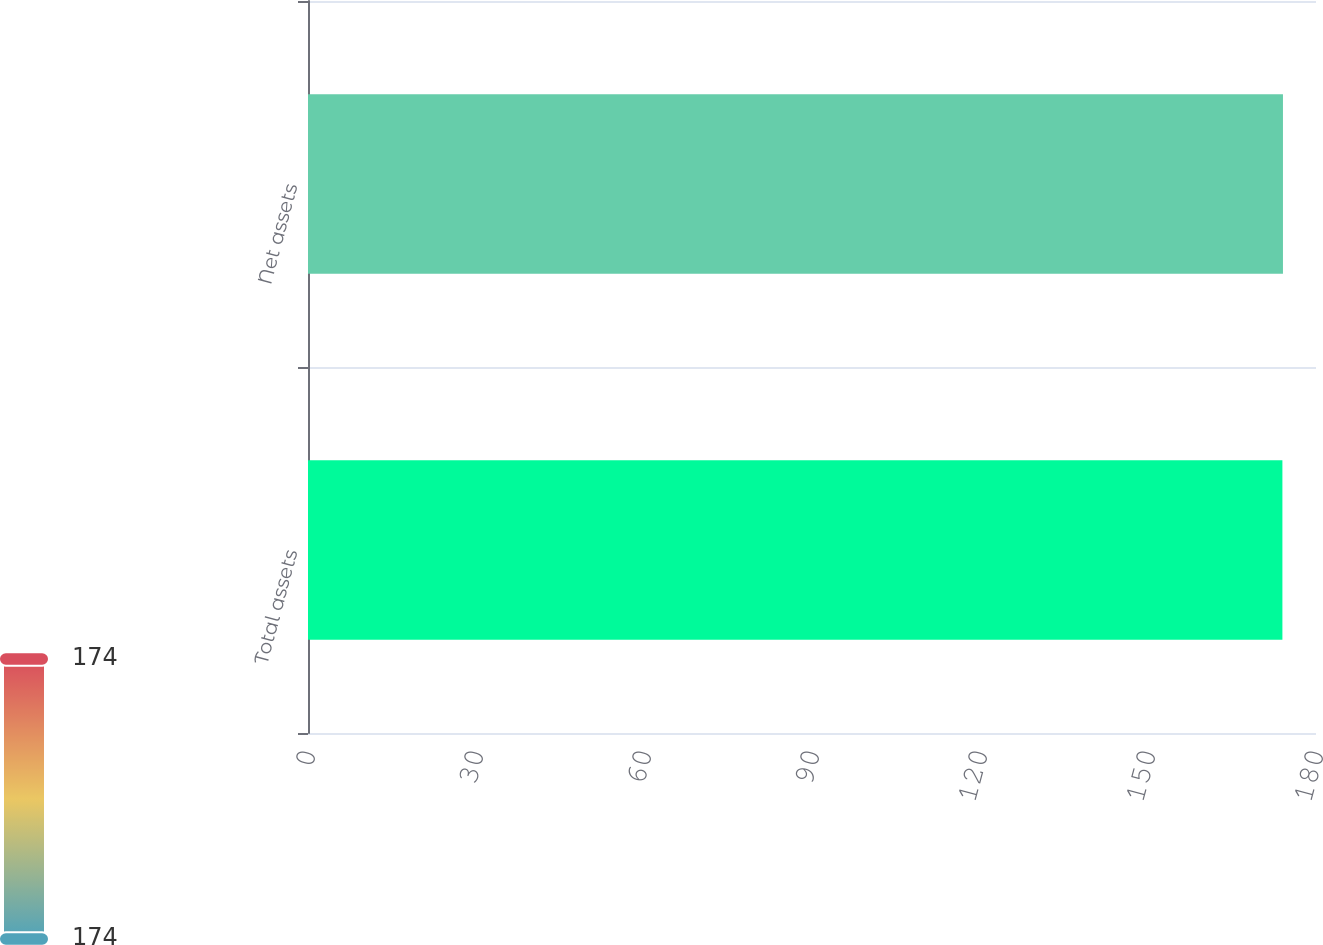<chart> <loc_0><loc_0><loc_500><loc_500><bar_chart><fcel>Total assets<fcel>Net assets<nl><fcel>174<fcel>174.1<nl></chart> 